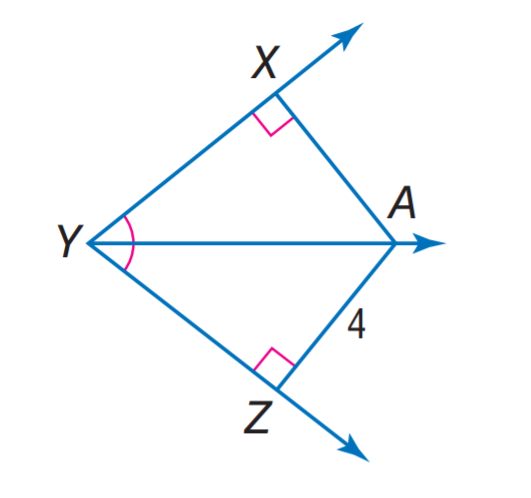Question: Find X A.
Choices:
A. 2
B. 4
C. 8
D. 16
Answer with the letter. Answer: B 